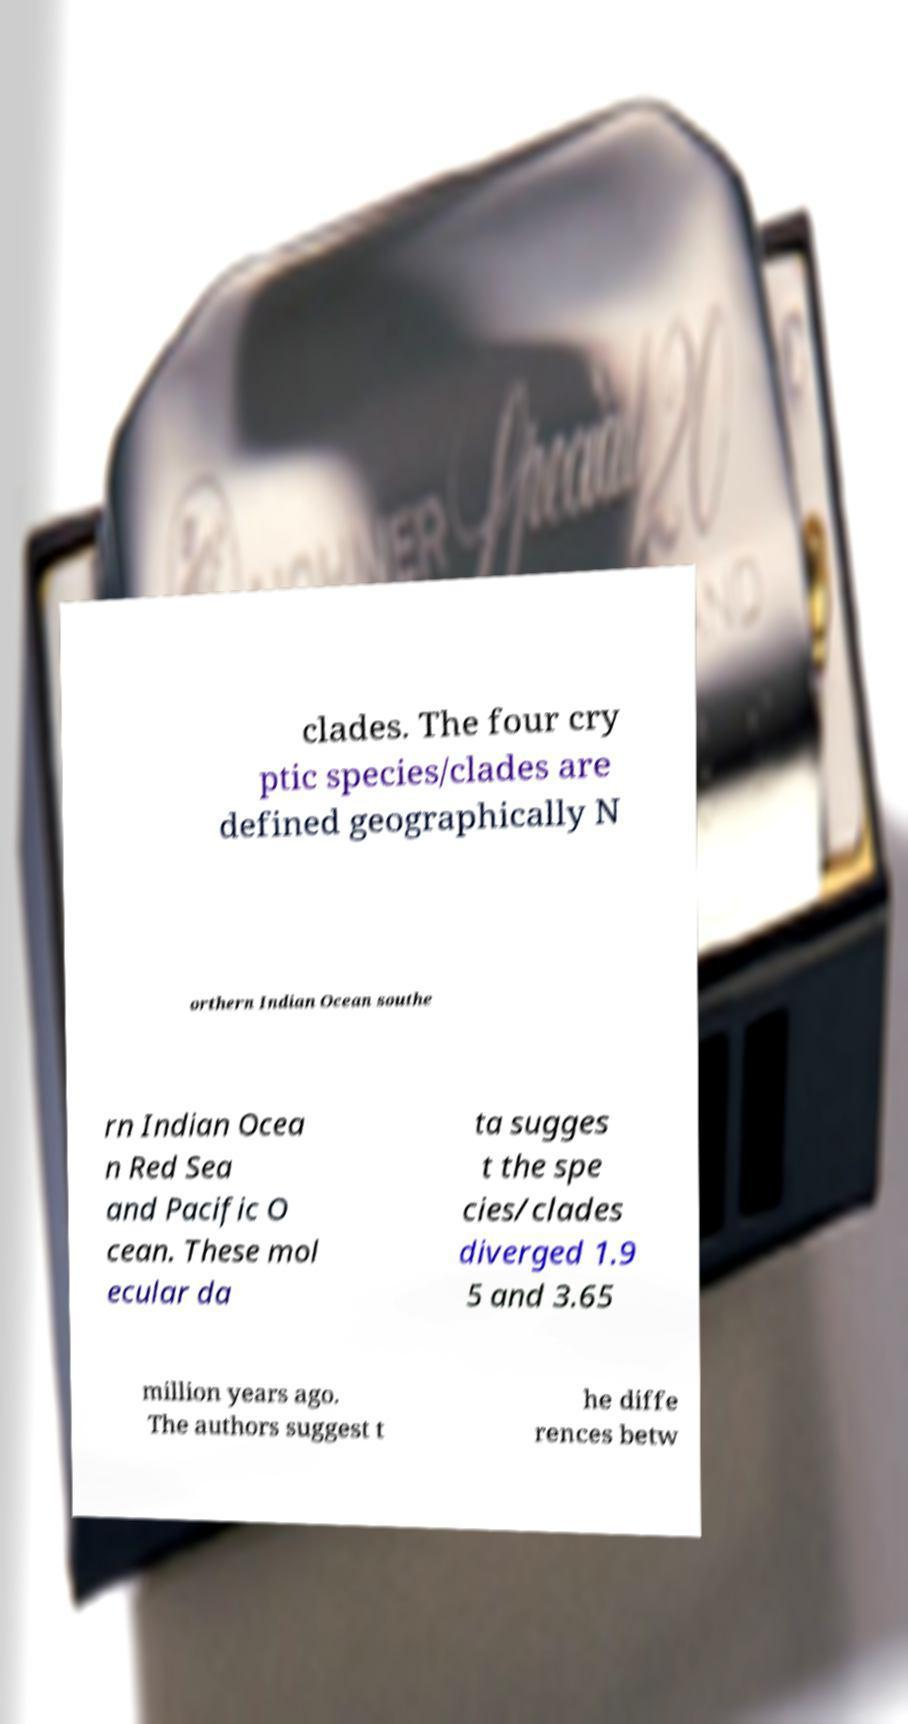Please identify and transcribe the text found in this image. clades. The four cry ptic species/clades are defined geographically N orthern Indian Ocean southe rn Indian Ocea n Red Sea and Pacific O cean. These mol ecular da ta sugges t the spe cies/clades diverged 1.9 5 and 3.65 million years ago. The authors suggest t he diffe rences betw 